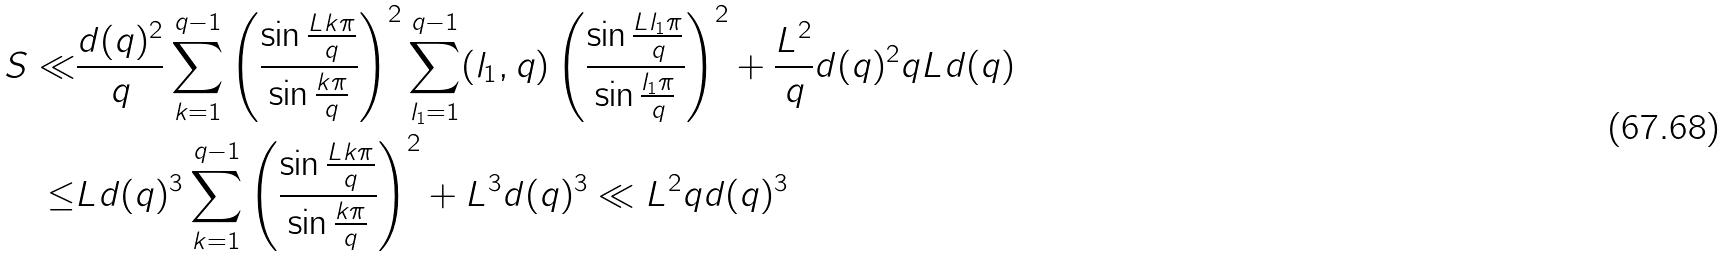<formula> <loc_0><loc_0><loc_500><loc_500>S \ll & \frac { d ( q ) ^ { 2 } } { q } \sum _ { k = 1 } ^ { q - 1 } \left ( \frac { \sin \frac { L k \pi } { q } } { \sin \frac { k \pi } { q } } \right ) ^ { 2 } \sum _ { l _ { 1 } = 1 } ^ { q - 1 } ( l _ { 1 } , q ) \left ( \frac { \sin \frac { L l _ { 1 } \pi } { q } } { \sin \frac { l _ { 1 } \pi } { q } } \right ) ^ { 2 } + \frac { L ^ { 2 } } { q } d ( q ) ^ { 2 } q L d ( q ) \\ \leq & L d ( q ) ^ { 3 } \sum _ { k = 1 } ^ { q - 1 } \left ( \frac { \sin \frac { L k \pi } { q } } { \sin \frac { k \pi } { q } } \right ) ^ { 2 } + L ^ { 3 } d ( q ) ^ { 3 } \ll L ^ { 2 } q d ( q ) ^ { 3 }</formula> 